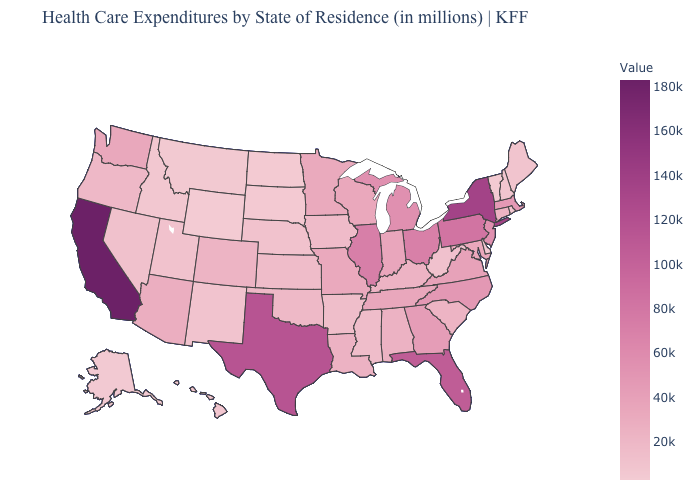Among the states that border Iowa , does Nebraska have the lowest value?
Be succinct. No. Does Wisconsin have a higher value than Utah?
Keep it brief. Yes. Does Wyoming have the lowest value in the USA?
Quick response, please. Yes. Does California have the highest value in the USA?
Short answer required. Yes. Which states have the lowest value in the South?
Give a very brief answer. Delaware. Among the states that border Washington , which have the highest value?
Write a very short answer. Oregon. Does Alabama have the highest value in the USA?
Be succinct. No. Which states have the lowest value in the USA?
Concise answer only. Wyoming. 